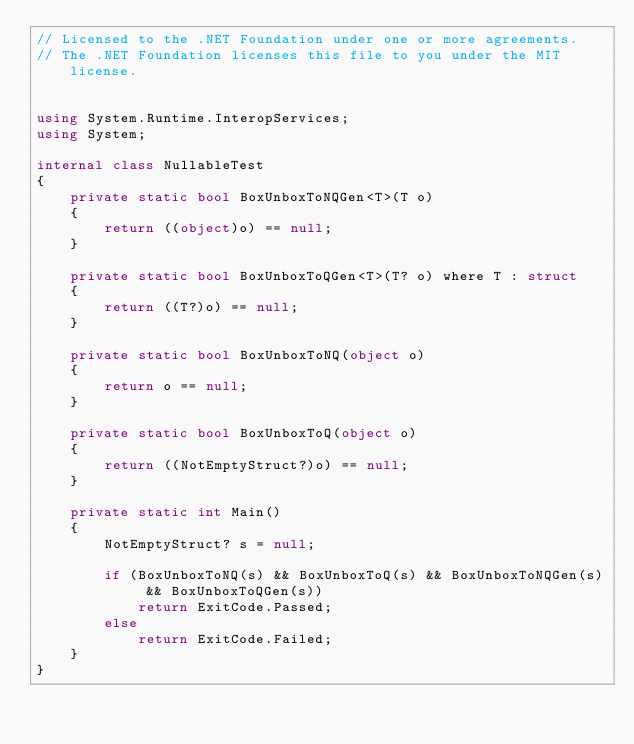Convert code to text. <code><loc_0><loc_0><loc_500><loc_500><_C#_>// Licensed to the .NET Foundation under one or more agreements.
// The .NET Foundation licenses this file to you under the MIT license.


using System.Runtime.InteropServices;
using System;

internal class NullableTest
{
    private static bool BoxUnboxToNQGen<T>(T o)
    {
        return ((object)o) == null;
    }

    private static bool BoxUnboxToQGen<T>(T? o) where T : struct
    {
        return ((T?)o) == null;
    }

    private static bool BoxUnboxToNQ(object o)
    {
        return o == null;
    }

    private static bool BoxUnboxToQ(object o)
    {
        return ((NotEmptyStruct?)o) == null;
    }

    private static int Main()
    {
        NotEmptyStruct? s = null;

        if (BoxUnboxToNQ(s) && BoxUnboxToQ(s) && BoxUnboxToNQGen(s) && BoxUnboxToQGen(s))
            return ExitCode.Passed;
        else
            return ExitCode.Failed;
    }
}


</code> 